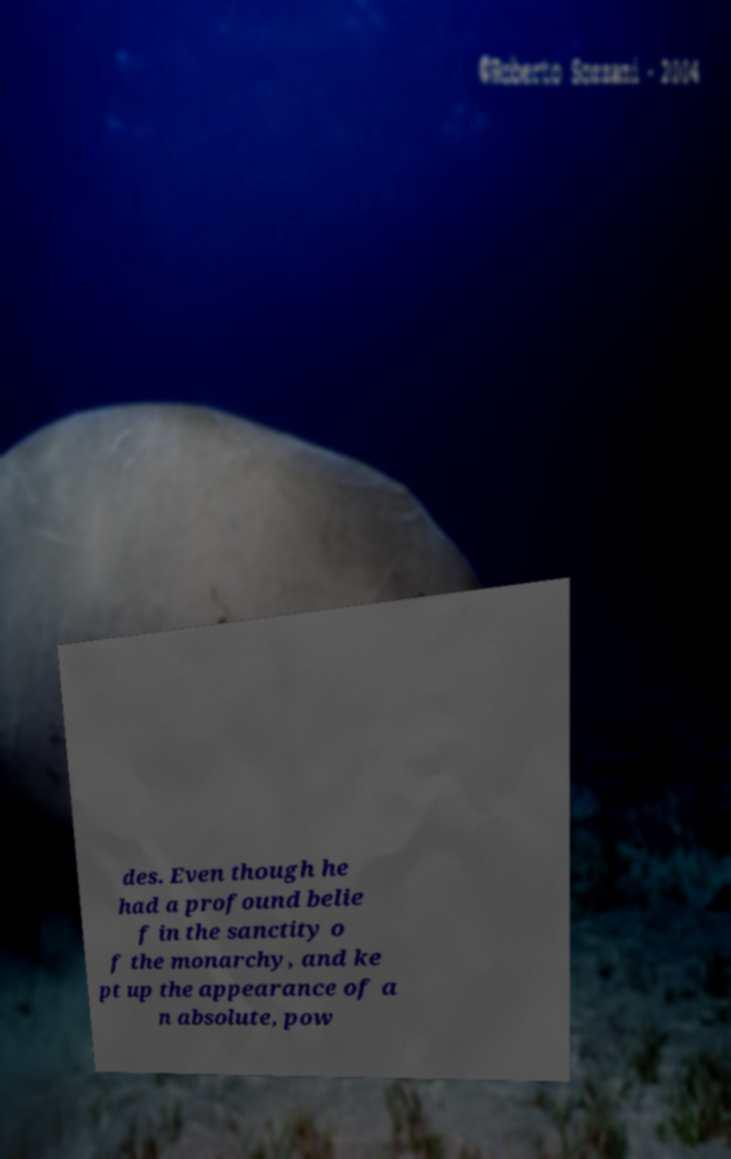What messages or text are displayed in this image? I need them in a readable, typed format. des. Even though he had a profound belie f in the sanctity o f the monarchy, and ke pt up the appearance of a n absolute, pow 